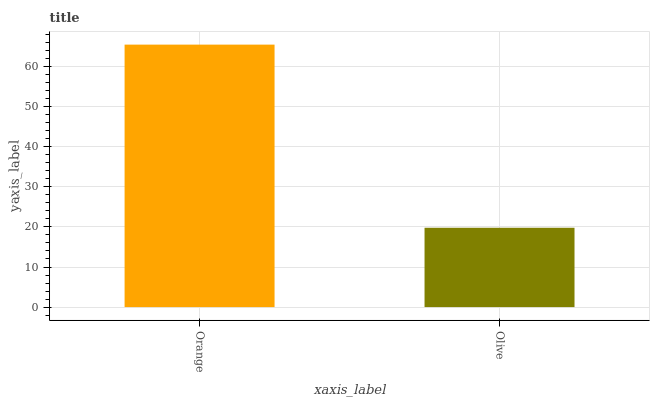Is Olive the minimum?
Answer yes or no. Yes. Is Orange the maximum?
Answer yes or no. Yes. Is Olive the maximum?
Answer yes or no. No. Is Orange greater than Olive?
Answer yes or no. Yes. Is Olive less than Orange?
Answer yes or no. Yes. Is Olive greater than Orange?
Answer yes or no. No. Is Orange less than Olive?
Answer yes or no. No. Is Orange the high median?
Answer yes or no. Yes. Is Olive the low median?
Answer yes or no. Yes. Is Olive the high median?
Answer yes or no. No. Is Orange the low median?
Answer yes or no. No. 